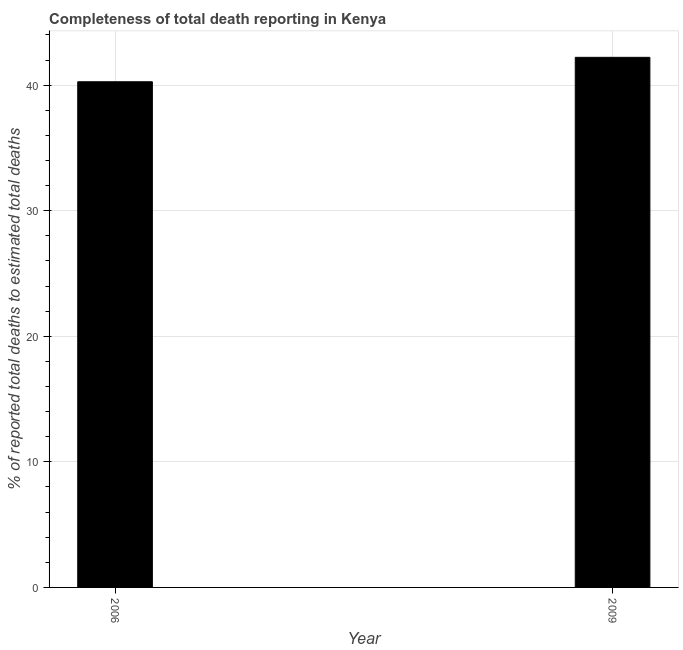Does the graph contain grids?
Give a very brief answer. Yes. What is the title of the graph?
Provide a short and direct response. Completeness of total death reporting in Kenya. What is the label or title of the Y-axis?
Give a very brief answer. % of reported total deaths to estimated total deaths. What is the completeness of total death reports in 2009?
Provide a succinct answer. 42.22. Across all years, what is the maximum completeness of total death reports?
Offer a very short reply. 42.22. Across all years, what is the minimum completeness of total death reports?
Ensure brevity in your answer.  40.27. In which year was the completeness of total death reports maximum?
Your answer should be very brief. 2009. What is the sum of the completeness of total death reports?
Your answer should be very brief. 82.49. What is the difference between the completeness of total death reports in 2006 and 2009?
Your answer should be very brief. -1.95. What is the average completeness of total death reports per year?
Make the answer very short. 41.25. What is the median completeness of total death reports?
Keep it short and to the point. 41.25. What is the ratio of the completeness of total death reports in 2006 to that in 2009?
Keep it short and to the point. 0.95. Is the completeness of total death reports in 2006 less than that in 2009?
Provide a short and direct response. Yes. In how many years, is the completeness of total death reports greater than the average completeness of total death reports taken over all years?
Your response must be concise. 1. How many bars are there?
Provide a short and direct response. 2. Are all the bars in the graph horizontal?
Keep it short and to the point. No. How many years are there in the graph?
Give a very brief answer. 2. What is the % of reported total deaths to estimated total deaths in 2006?
Provide a succinct answer. 40.27. What is the % of reported total deaths to estimated total deaths in 2009?
Make the answer very short. 42.22. What is the difference between the % of reported total deaths to estimated total deaths in 2006 and 2009?
Ensure brevity in your answer.  -1.95. What is the ratio of the % of reported total deaths to estimated total deaths in 2006 to that in 2009?
Your answer should be compact. 0.95. 